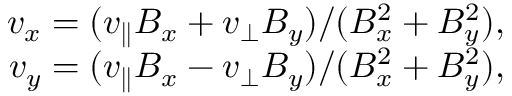<formula> <loc_0><loc_0><loc_500><loc_500>\begin{array} { r } { v _ { x } = ( v _ { \| } B _ { x } + v _ { \perp } B _ { y } ) / ( B _ { x } ^ { 2 } + B _ { y } ^ { 2 } ) , } \\ { v _ { y } = ( v _ { \| } B _ { x } - v _ { \perp } B _ { y } ) / ( B _ { x } ^ { 2 } + B _ { y } ^ { 2 } ) , } \end{array}</formula> 